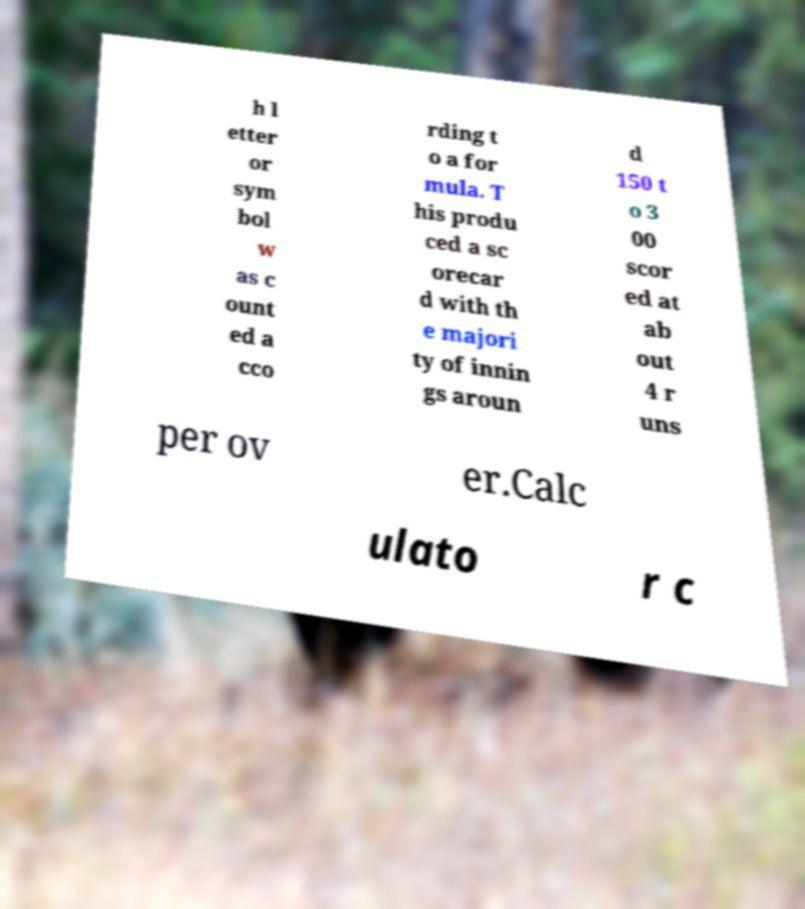I need the written content from this picture converted into text. Can you do that? h l etter or sym bol w as c ount ed a cco rding t o a for mula. T his produ ced a sc orecar d with th e majori ty of innin gs aroun d 150 t o 3 00 scor ed at ab out 4 r uns per ov er.Calc ulato r c 